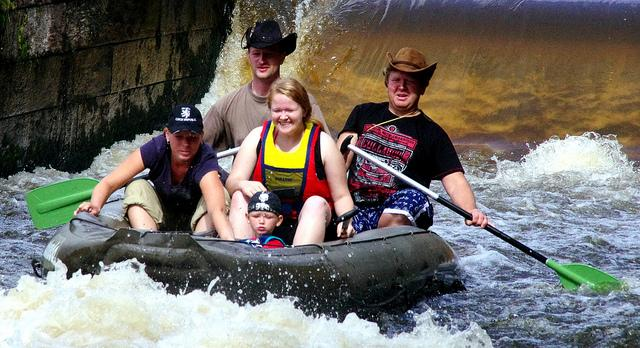What is this boat called? raft 